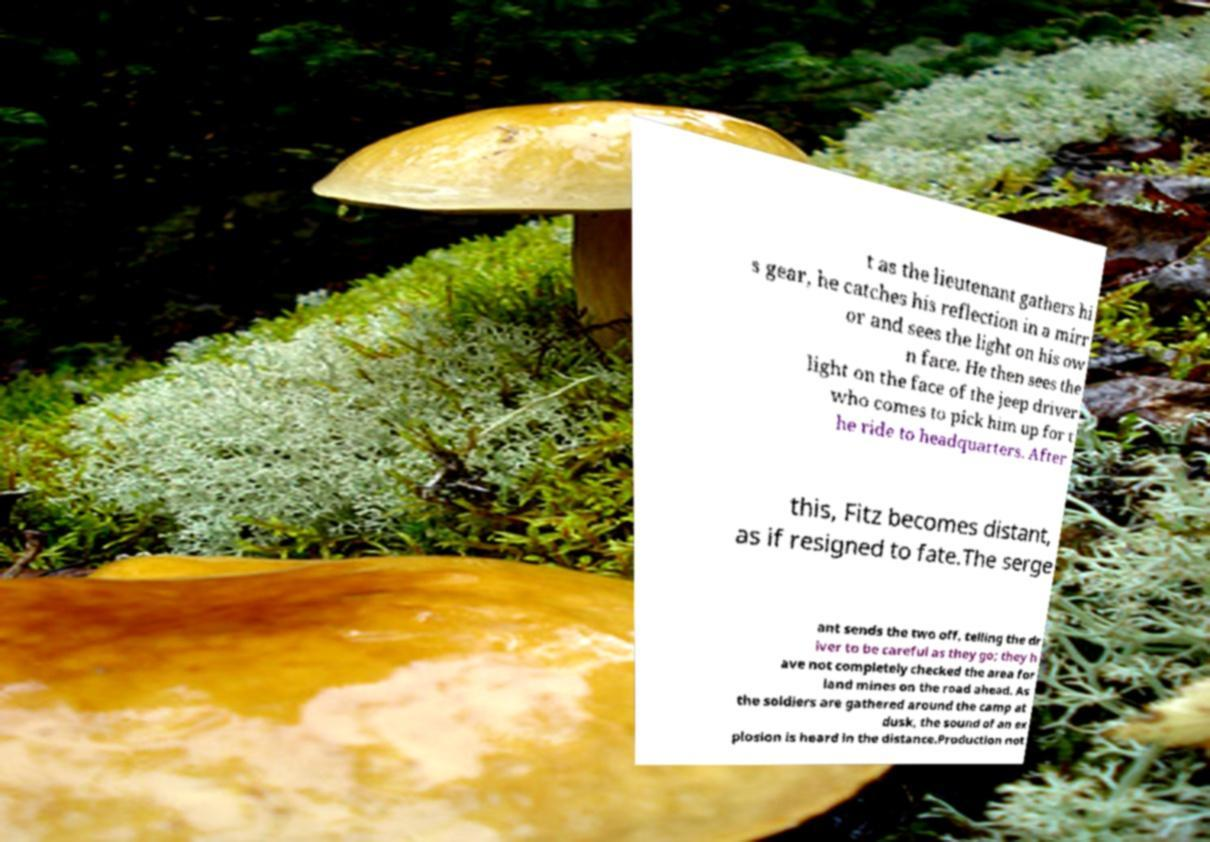Could you assist in decoding the text presented in this image and type it out clearly? t as the lieutenant gathers hi s gear, he catches his reflection in a mirr or and sees the light on his ow n face. He then sees the light on the face of the jeep driver who comes to pick him up for t he ride to headquarters. After this, Fitz becomes distant, as if resigned to fate.The serge ant sends the two off, telling the dr iver to be careful as they go; they h ave not completely checked the area for land mines on the road ahead. As the soldiers are gathered around the camp at dusk, the sound of an ex plosion is heard in the distance.Production not 